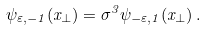Convert formula to latex. <formula><loc_0><loc_0><loc_500><loc_500>\psi _ { \varepsilon , - 1 } ( x _ { \perp } ) = \sigma ^ { 3 } \psi _ { - \varepsilon , 1 } ( x _ { \perp } ) \, .</formula> 